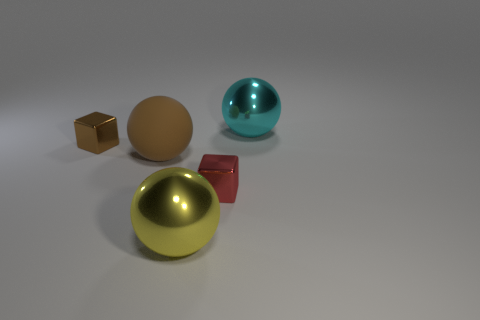Subtract all cyan spheres. How many spheres are left? 2 Add 1 big green balls. How many objects exist? 6 Subtract all spheres. How many objects are left? 2 Subtract all brown rubber things. Subtract all red metallic objects. How many objects are left? 3 Add 5 cyan metallic balls. How many cyan metallic balls are left? 6 Add 1 big cyan objects. How many big cyan objects exist? 2 Subtract 0 blue balls. How many objects are left? 5 Subtract all blue spheres. Subtract all green cubes. How many spheres are left? 3 